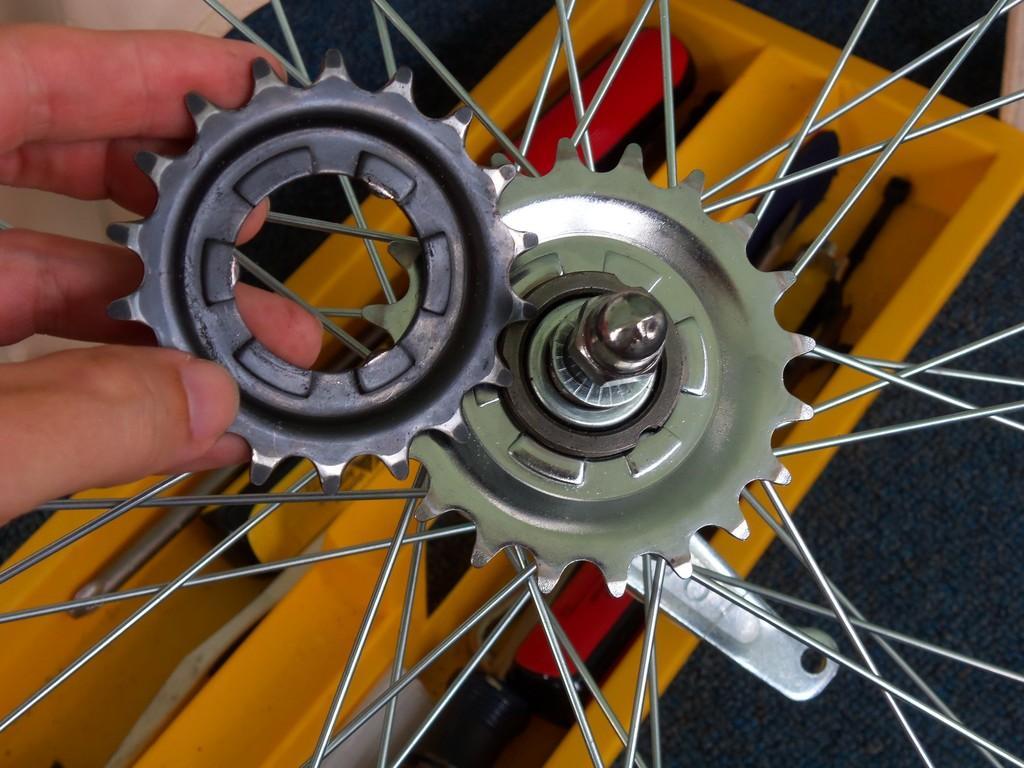Could you give a brief overview of what you see in this image? In this picture we can observe a wheel. There are rims. We can observe yellow color tool kit. On the left side we can observe a human hand. 